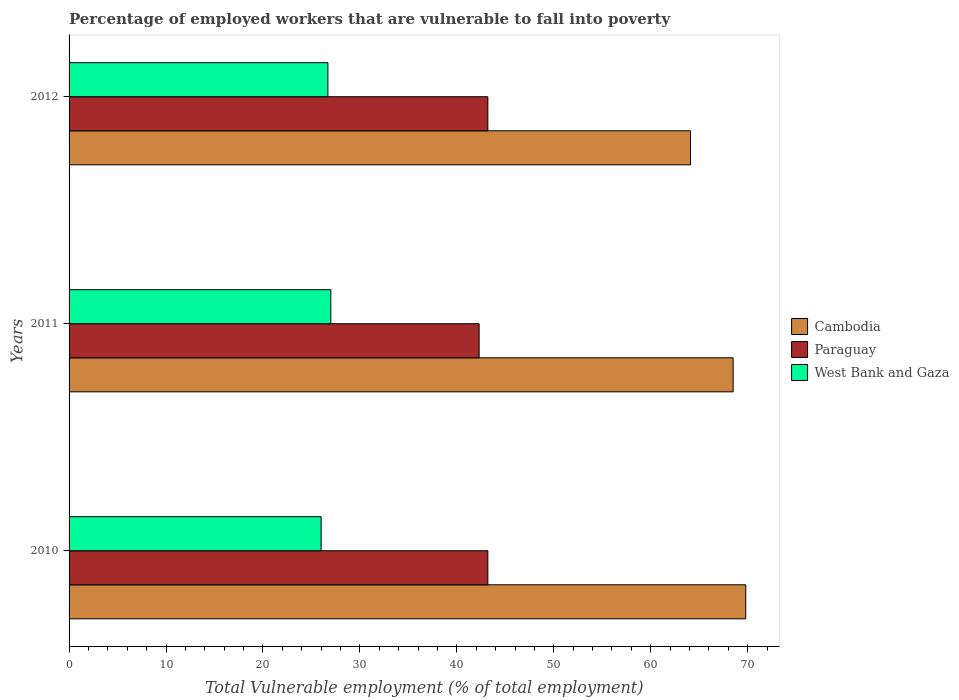How many groups of bars are there?
Offer a very short reply. 3. Are the number of bars per tick equal to the number of legend labels?
Ensure brevity in your answer.  Yes. How many bars are there on the 3rd tick from the bottom?
Offer a terse response. 3. What is the percentage of employed workers who are vulnerable to fall into poverty in Paraguay in 2011?
Offer a terse response. 42.3. Across all years, what is the maximum percentage of employed workers who are vulnerable to fall into poverty in Cambodia?
Ensure brevity in your answer.  69.8. Across all years, what is the minimum percentage of employed workers who are vulnerable to fall into poverty in Cambodia?
Offer a very short reply. 64.1. In which year was the percentage of employed workers who are vulnerable to fall into poverty in Paraguay minimum?
Provide a succinct answer. 2011. What is the total percentage of employed workers who are vulnerable to fall into poverty in Cambodia in the graph?
Your answer should be compact. 202.4. What is the difference between the percentage of employed workers who are vulnerable to fall into poverty in Paraguay in 2011 and that in 2012?
Your answer should be compact. -0.9. What is the difference between the percentage of employed workers who are vulnerable to fall into poverty in West Bank and Gaza in 2010 and the percentage of employed workers who are vulnerable to fall into poverty in Cambodia in 2011?
Your answer should be very brief. -42.5. What is the average percentage of employed workers who are vulnerable to fall into poverty in Paraguay per year?
Offer a terse response. 42.9. In the year 2012, what is the difference between the percentage of employed workers who are vulnerable to fall into poverty in Cambodia and percentage of employed workers who are vulnerable to fall into poverty in West Bank and Gaza?
Offer a terse response. 37.4. Is the percentage of employed workers who are vulnerable to fall into poverty in Cambodia in 2010 less than that in 2011?
Keep it short and to the point. No. Is the difference between the percentage of employed workers who are vulnerable to fall into poverty in Cambodia in 2010 and 2012 greater than the difference between the percentage of employed workers who are vulnerable to fall into poverty in West Bank and Gaza in 2010 and 2012?
Your answer should be very brief. Yes. What is the difference between the highest and the second highest percentage of employed workers who are vulnerable to fall into poverty in Cambodia?
Offer a terse response. 1.3. What is the difference between the highest and the lowest percentage of employed workers who are vulnerable to fall into poverty in Paraguay?
Your response must be concise. 0.9. In how many years, is the percentage of employed workers who are vulnerable to fall into poverty in Cambodia greater than the average percentage of employed workers who are vulnerable to fall into poverty in Cambodia taken over all years?
Provide a short and direct response. 2. Is the sum of the percentage of employed workers who are vulnerable to fall into poverty in Paraguay in 2010 and 2011 greater than the maximum percentage of employed workers who are vulnerable to fall into poverty in West Bank and Gaza across all years?
Make the answer very short. Yes. What does the 1st bar from the top in 2012 represents?
Provide a succinct answer. West Bank and Gaza. What does the 1st bar from the bottom in 2010 represents?
Provide a short and direct response. Cambodia. Is it the case that in every year, the sum of the percentage of employed workers who are vulnerable to fall into poverty in Paraguay and percentage of employed workers who are vulnerable to fall into poverty in West Bank and Gaza is greater than the percentage of employed workers who are vulnerable to fall into poverty in Cambodia?
Provide a succinct answer. No. Are all the bars in the graph horizontal?
Your answer should be very brief. Yes. Are the values on the major ticks of X-axis written in scientific E-notation?
Provide a succinct answer. No. Does the graph contain any zero values?
Provide a short and direct response. No. Does the graph contain grids?
Offer a terse response. No. How many legend labels are there?
Give a very brief answer. 3. How are the legend labels stacked?
Make the answer very short. Vertical. What is the title of the graph?
Offer a very short reply. Percentage of employed workers that are vulnerable to fall into poverty. What is the label or title of the X-axis?
Keep it short and to the point. Total Vulnerable employment (% of total employment). What is the Total Vulnerable employment (% of total employment) in Cambodia in 2010?
Offer a terse response. 69.8. What is the Total Vulnerable employment (% of total employment) of Paraguay in 2010?
Keep it short and to the point. 43.2. What is the Total Vulnerable employment (% of total employment) of Cambodia in 2011?
Give a very brief answer. 68.5. What is the Total Vulnerable employment (% of total employment) in Paraguay in 2011?
Give a very brief answer. 42.3. What is the Total Vulnerable employment (% of total employment) in Cambodia in 2012?
Your answer should be compact. 64.1. What is the Total Vulnerable employment (% of total employment) of Paraguay in 2012?
Your answer should be very brief. 43.2. What is the Total Vulnerable employment (% of total employment) in West Bank and Gaza in 2012?
Provide a succinct answer. 26.7. Across all years, what is the maximum Total Vulnerable employment (% of total employment) of Cambodia?
Your answer should be compact. 69.8. Across all years, what is the maximum Total Vulnerable employment (% of total employment) of Paraguay?
Provide a succinct answer. 43.2. Across all years, what is the maximum Total Vulnerable employment (% of total employment) of West Bank and Gaza?
Provide a short and direct response. 27. Across all years, what is the minimum Total Vulnerable employment (% of total employment) in Cambodia?
Provide a short and direct response. 64.1. Across all years, what is the minimum Total Vulnerable employment (% of total employment) in Paraguay?
Provide a short and direct response. 42.3. Across all years, what is the minimum Total Vulnerable employment (% of total employment) in West Bank and Gaza?
Offer a very short reply. 26. What is the total Total Vulnerable employment (% of total employment) of Cambodia in the graph?
Give a very brief answer. 202.4. What is the total Total Vulnerable employment (% of total employment) of Paraguay in the graph?
Ensure brevity in your answer.  128.7. What is the total Total Vulnerable employment (% of total employment) in West Bank and Gaza in the graph?
Make the answer very short. 79.7. What is the difference between the Total Vulnerable employment (% of total employment) of Cambodia in 2010 and that in 2011?
Your response must be concise. 1.3. What is the difference between the Total Vulnerable employment (% of total employment) in West Bank and Gaza in 2010 and that in 2011?
Ensure brevity in your answer.  -1. What is the difference between the Total Vulnerable employment (% of total employment) in Paraguay in 2011 and that in 2012?
Provide a succinct answer. -0.9. What is the difference between the Total Vulnerable employment (% of total employment) of Cambodia in 2010 and the Total Vulnerable employment (% of total employment) of Paraguay in 2011?
Make the answer very short. 27.5. What is the difference between the Total Vulnerable employment (% of total employment) of Cambodia in 2010 and the Total Vulnerable employment (% of total employment) of West Bank and Gaza in 2011?
Your response must be concise. 42.8. What is the difference between the Total Vulnerable employment (% of total employment) in Cambodia in 2010 and the Total Vulnerable employment (% of total employment) in Paraguay in 2012?
Your answer should be compact. 26.6. What is the difference between the Total Vulnerable employment (% of total employment) of Cambodia in 2010 and the Total Vulnerable employment (% of total employment) of West Bank and Gaza in 2012?
Keep it short and to the point. 43.1. What is the difference between the Total Vulnerable employment (% of total employment) of Paraguay in 2010 and the Total Vulnerable employment (% of total employment) of West Bank and Gaza in 2012?
Provide a short and direct response. 16.5. What is the difference between the Total Vulnerable employment (% of total employment) of Cambodia in 2011 and the Total Vulnerable employment (% of total employment) of Paraguay in 2012?
Make the answer very short. 25.3. What is the difference between the Total Vulnerable employment (% of total employment) of Cambodia in 2011 and the Total Vulnerable employment (% of total employment) of West Bank and Gaza in 2012?
Offer a terse response. 41.8. What is the difference between the Total Vulnerable employment (% of total employment) in Paraguay in 2011 and the Total Vulnerable employment (% of total employment) in West Bank and Gaza in 2012?
Your answer should be very brief. 15.6. What is the average Total Vulnerable employment (% of total employment) of Cambodia per year?
Make the answer very short. 67.47. What is the average Total Vulnerable employment (% of total employment) of Paraguay per year?
Make the answer very short. 42.9. What is the average Total Vulnerable employment (% of total employment) in West Bank and Gaza per year?
Ensure brevity in your answer.  26.57. In the year 2010, what is the difference between the Total Vulnerable employment (% of total employment) of Cambodia and Total Vulnerable employment (% of total employment) of Paraguay?
Keep it short and to the point. 26.6. In the year 2010, what is the difference between the Total Vulnerable employment (% of total employment) of Cambodia and Total Vulnerable employment (% of total employment) of West Bank and Gaza?
Make the answer very short. 43.8. In the year 2011, what is the difference between the Total Vulnerable employment (% of total employment) in Cambodia and Total Vulnerable employment (% of total employment) in Paraguay?
Keep it short and to the point. 26.2. In the year 2011, what is the difference between the Total Vulnerable employment (% of total employment) in Cambodia and Total Vulnerable employment (% of total employment) in West Bank and Gaza?
Your response must be concise. 41.5. In the year 2011, what is the difference between the Total Vulnerable employment (% of total employment) of Paraguay and Total Vulnerable employment (% of total employment) of West Bank and Gaza?
Offer a terse response. 15.3. In the year 2012, what is the difference between the Total Vulnerable employment (% of total employment) in Cambodia and Total Vulnerable employment (% of total employment) in Paraguay?
Make the answer very short. 20.9. In the year 2012, what is the difference between the Total Vulnerable employment (% of total employment) in Cambodia and Total Vulnerable employment (% of total employment) in West Bank and Gaza?
Offer a terse response. 37.4. What is the ratio of the Total Vulnerable employment (% of total employment) in Cambodia in 2010 to that in 2011?
Ensure brevity in your answer.  1.02. What is the ratio of the Total Vulnerable employment (% of total employment) in Paraguay in 2010 to that in 2011?
Your answer should be compact. 1.02. What is the ratio of the Total Vulnerable employment (% of total employment) of West Bank and Gaza in 2010 to that in 2011?
Make the answer very short. 0.96. What is the ratio of the Total Vulnerable employment (% of total employment) in Cambodia in 2010 to that in 2012?
Make the answer very short. 1.09. What is the ratio of the Total Vulnerable employment (% of total employment) in Paraguay in 2010 to that in 2012?
Your response must be concise. 1. What is the ratio of the Total Vulnerable employment (% of total employment) of West Bank and Gaza in 2010 to that in 2012?
Provide a succinct answer. 0.97. What is the ratio of the Total Vulnerable employment (% of total employment) in Cambodia in 2011 to that in 2012?
Make the answer very short. 1.07. What is the ratio of the Total Vulnerable employment (% of total employment) in Paraguay in 2011 to that in 2012?
Offer a very short reply. 0.98. What is the ratio of the Total Vulnerable employment (% of total employment) of West Bank and Gaza in 2011 to that in 2012?
Your response must be concise. 1.01. What is the difference between the highest and the second highest Total Vulnerable employment (% of total employment) of West Bank and Gaza?
Offer a terse response. 0.3. What is the difference between the highest and the lowest Total Vulnerable employment (% of total employment) of Cambodia?
Your answer should be compact. 5.7. 